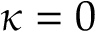<formula> <loc_0><loc_0><loc_500><loc_500>\kappa = 0</formula> 